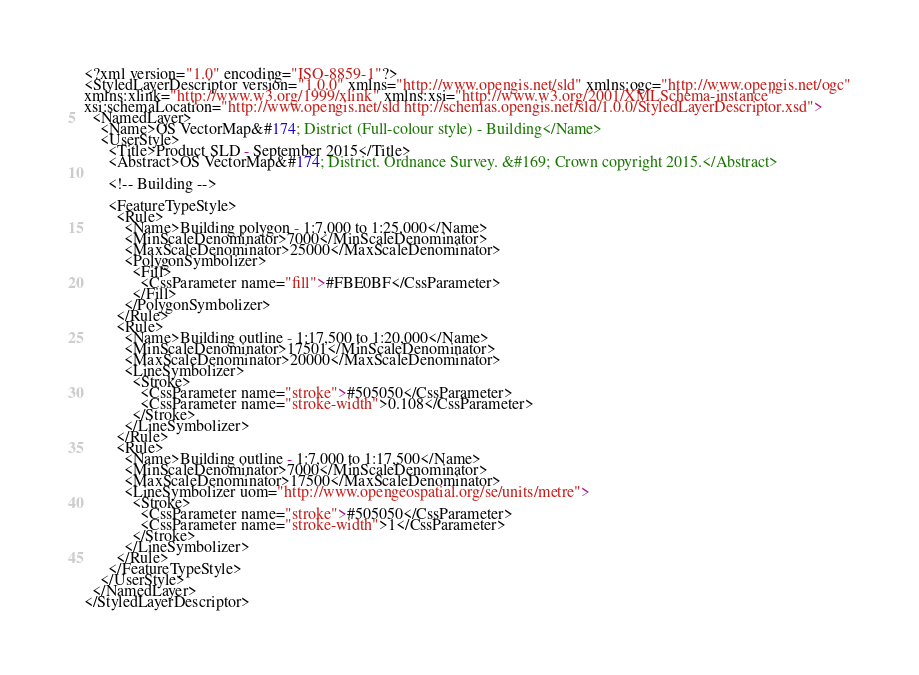Convert code to text. <code><loc_0><loc_0><loc_500><loc_500><_Scheme_><?xml version="1.0" encoding="ISO-8859-1"?>
<StyledLayerDescriptor version="1.0.0" xmlns="http://www.opengis.net/sld" xmlns:ogc="http://www.opengis.net/ogc"
xmlns:xlink="http://www.w3.org/1999/xlink" xmlns:xsi="http://www.w3.org/2001/XMLSchema-instance"
xsi:schemaLocation="http://www.opengis.net/sld http://schemas.opengis.net/sld/1.0.0/StyledLayerDescriptor.xsd">
  <NamedLayer>
    <Name>OS VectorMap&#174; District (Full-colour style) - Building</Name>
    <UserStyle>
      <Title>Product SLD - September 2015</Title>
      <Abstract>OS VectorMap&#174; District. Ordnance Survey. &#169; Crown copyright 2015.</Abstract>
      
      <!-- Building -->       
      
      <FeatureTypeStyle>
        <Rule>
          <Name>Building polygon - 1:7,000 to 1:25,000</Name>
          <MinScaleDenominator>7000</MinScaleDenominator>
          <MaxScaleDenominator>25000</MaxScaleDenominator>        
          <PolygonSymbolizer>
            <Fill>
              <CssParameter name="fill">#FBE0BF</CssParameter>
            </Fill>
          </PolygonSymbolizer>
        </Rule>
        <Rule>
          <Name>Building outline - 1:17,500 to 1:20,000</Name>
          <MinScaleDenominator>17501</MinScaleDenominator>
          <MaxScaleDenominator>20000</MaxScaleDenominator>       
          <LineSymbolizer>
            <Stroke>
              <CssParameter name="stroke">#505050</CssParameter>
              <CssParameter name="stroke-width">0.108</CssParameter>
            </Stroke>
          </LineSymbolizer>       
        </Rule>
        <Rule>
          <Name>Building outline - 1:7,000 to 1:17,500</Name>
          <MinScaleDenominator>7000</MinScaleDenominator>
          <MaxScaleDenominator>17500</MaxScaleDenominator>       
          <LineSymbolizer uom="http://www.opengeospatial.org/se/units/metre">
            <Stroke>
              <CssParameter name="stroke">#505050</CssParameter>
              <CssParameter name="stroke-width">1</CssParameter>
            </Stroke>
          </LineSymbolizer>       
        </Rule>  
      </FeatureTypeStyle>
    </UserStyle>
  </NamedLayer>
</StyledLayerDescriptor></code> 